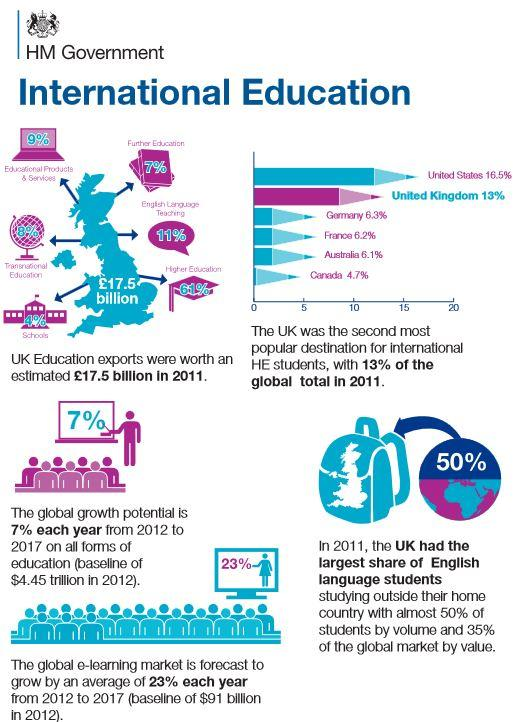List a handful of essential elements in this visual. The United Kingdom's education exports are dominated by higher education, which accounts for 61% of the country's total education exports. Germany is the third most popular destination for international students, according to data. 